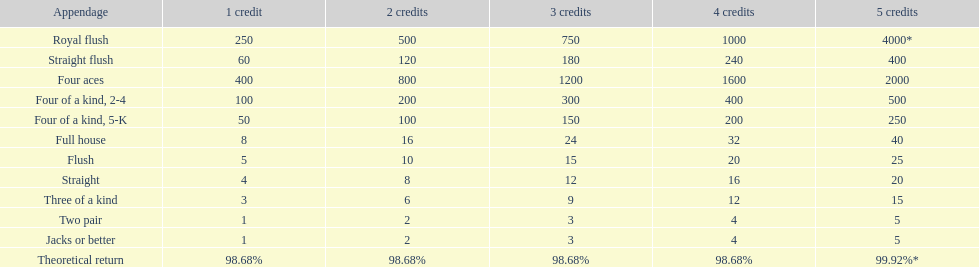At most, what could a person earn for having a full house? 40. 